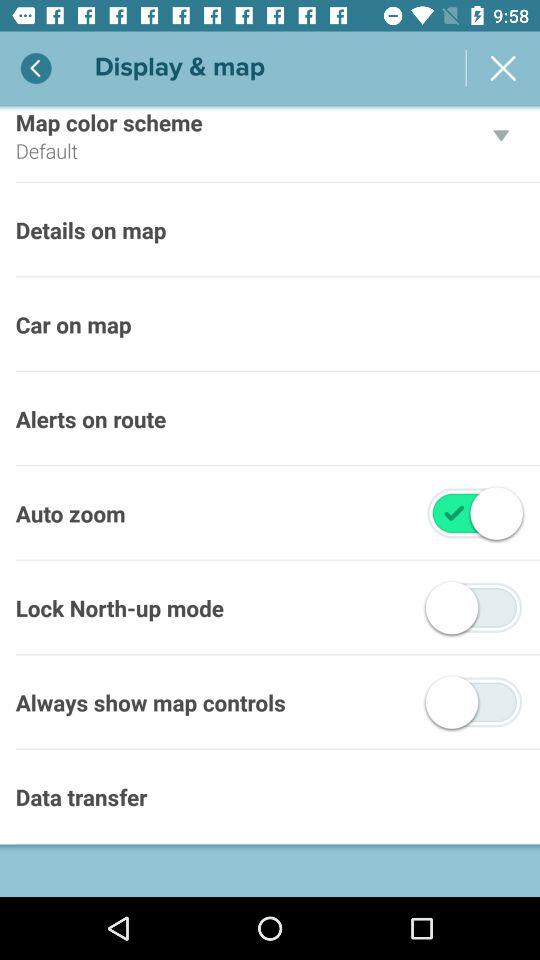What is the setting for map color scheme? The setting for map color scheme is "Default". 